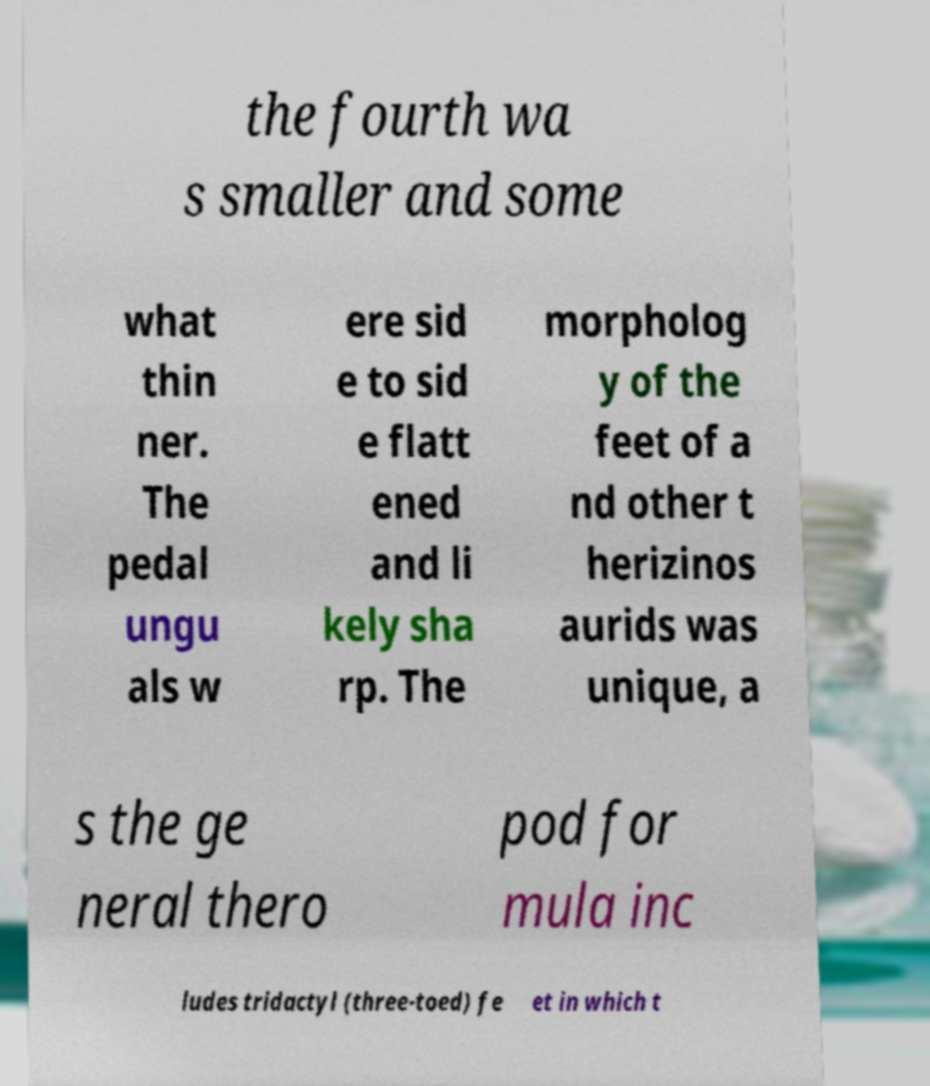Can you read and provide the text displayed in the image?This photo seems to have some interesting text. Can you extract and type it out for me? the fourth wa s smaller and some what thin ner. The pedal ungu als w ere sid e to sid e flatt ened and li kely sha rp. The morpholog y of the feet of a nd other t herizinos aurids was unique, a s the ge neral thero pod for mula inc ludes tridactyl (three-toed) fe et in which t 